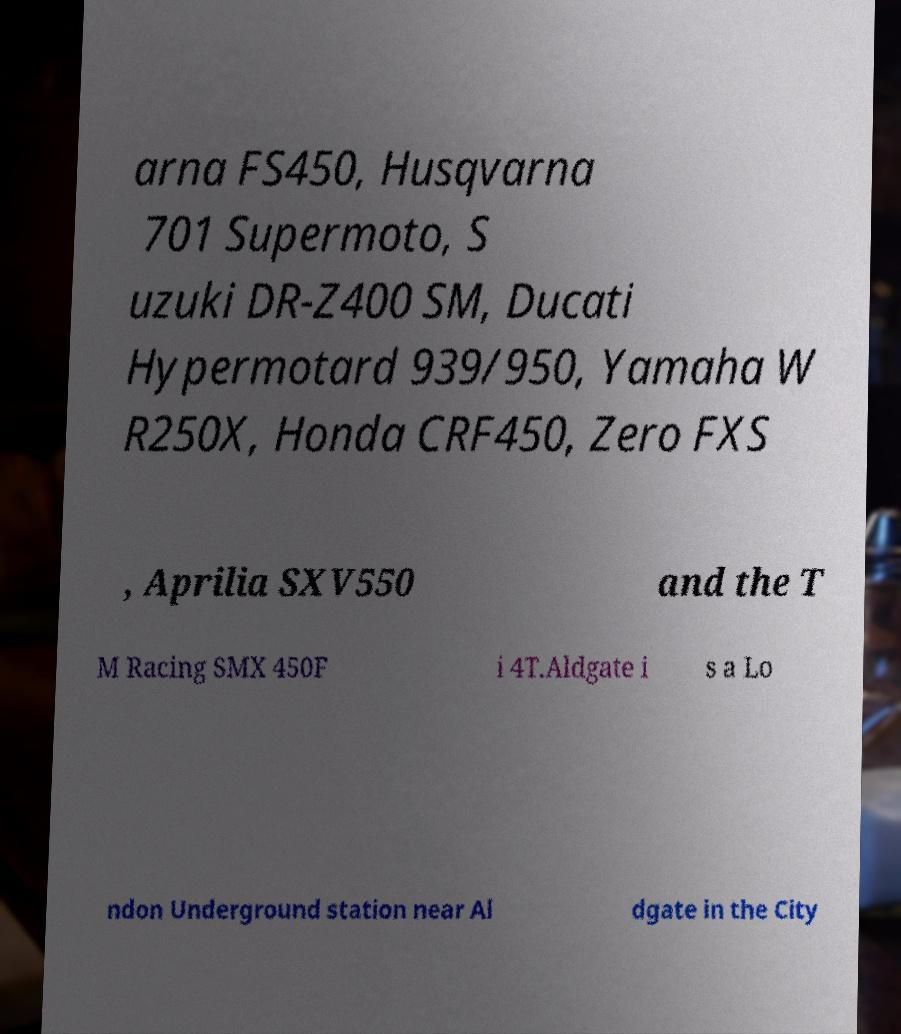What messages or text are displayed in this image? I need them in a readable, typed format. arna FS450, Husqvarna 701 Supermoto, S uzuki DR-Z400 SM, Ducati Hypermotard 939/950, Yamaha W R250X, Honda CRF450, Zero FXS , Aprilia SXV550 and the T M Racing SMX 450F i 4T.Aldgate i s a Lo ndon Underground station near Al dgate in the City 